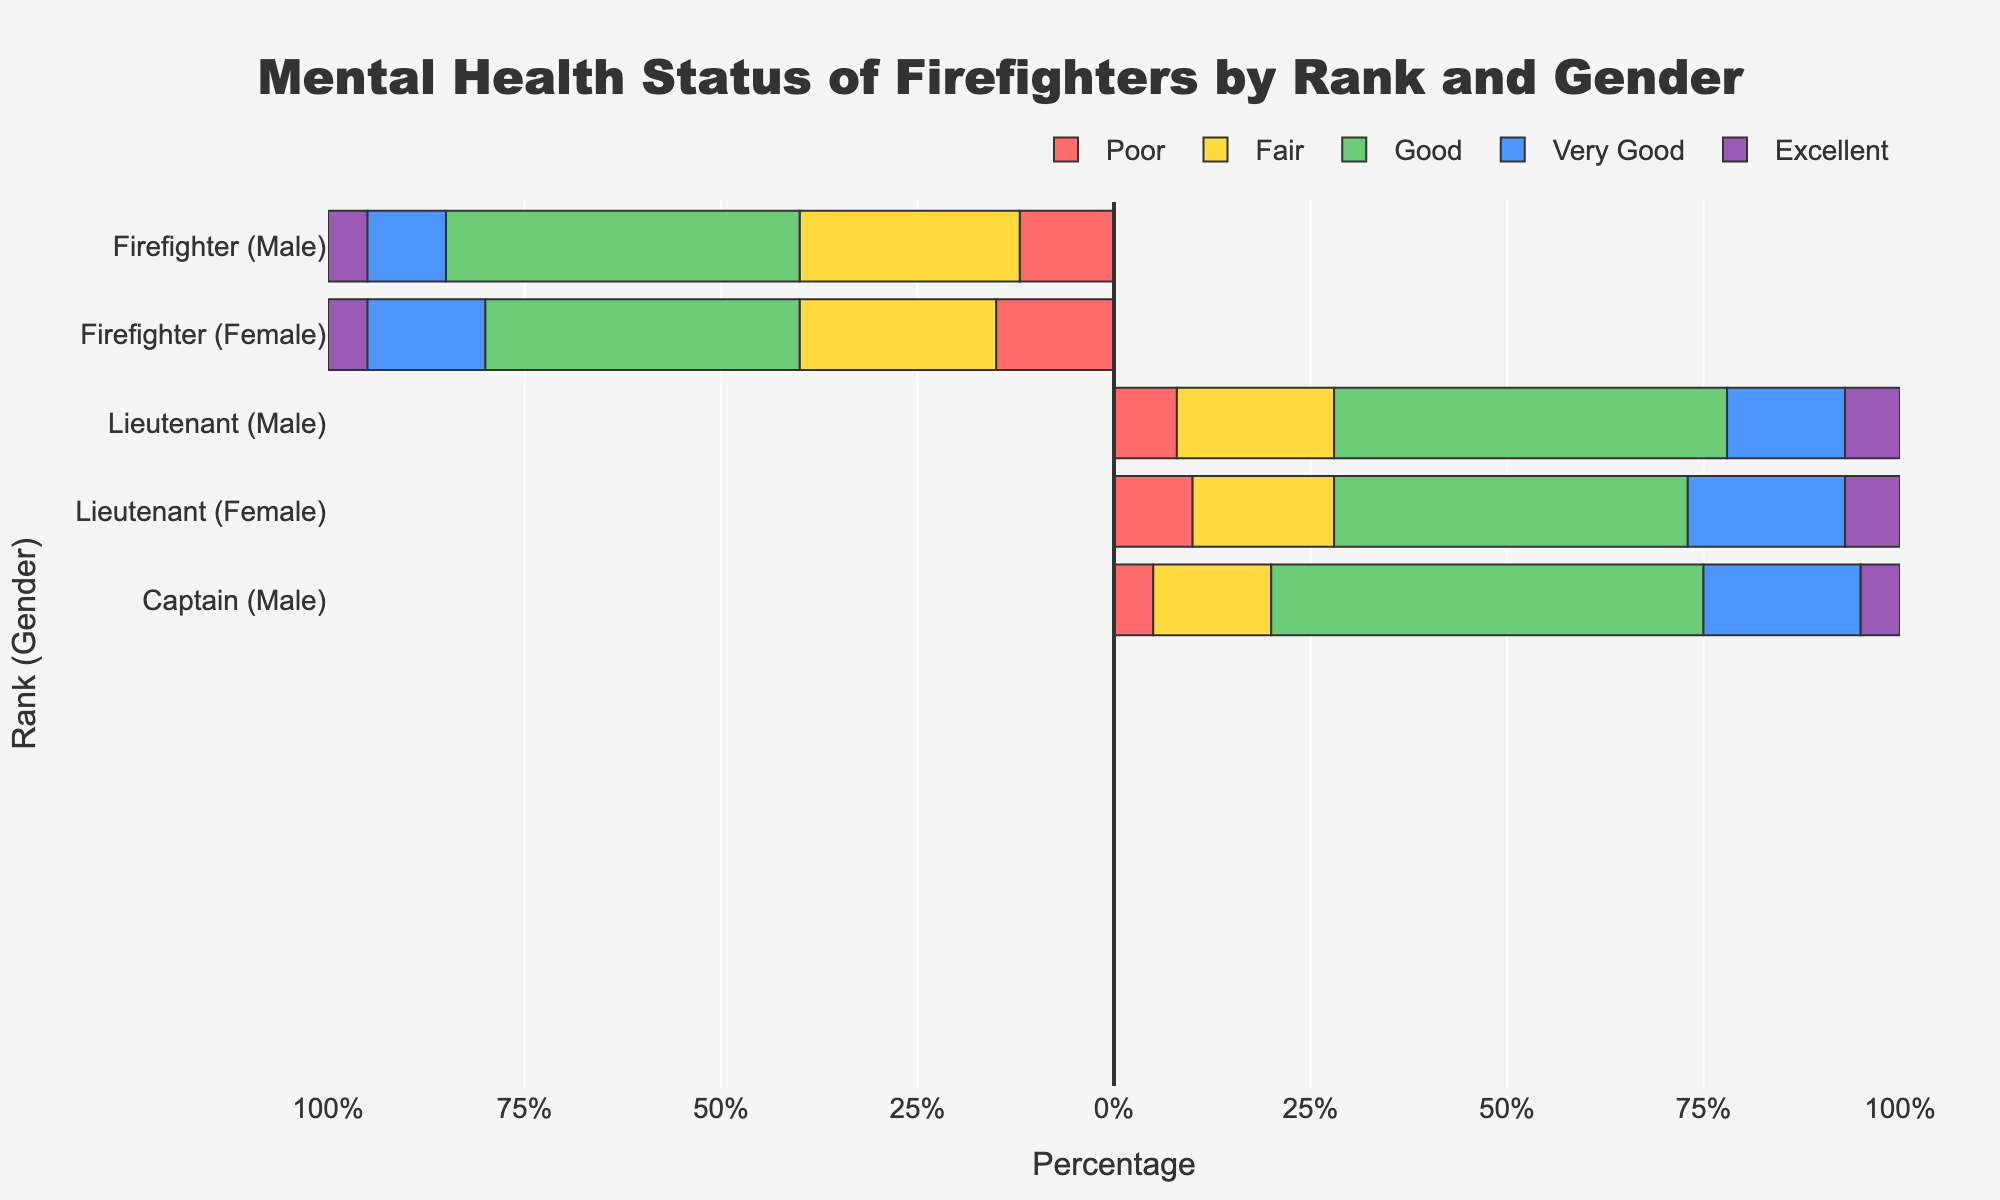What percentage of female Battalion Chiefs rate their mental health as Very Good? The figure shows a horizontal bar for Battalion Chiefs (Female). The "Very Good" category is represented by 30%, as indicated by the length of the light blue bar for that category.
Answer: 30% Which rank and gender combination has the highest percentage reporting their mental health as Excellent? The figure indicates the percentage reporting "Excellent" by the length of the purple bar. The Assistant Chief (Female) has the longest purple bar representing 14%.
Answer: Assistant Chief (Female) Between male and female Captains, which group has a higher percentage reporting their mental health as Poor? Compare the length of the red bars for Captains (Male) and Captains (Female). The red bar is longer for female Captains, showing a 8% compared to 5% for male Captains.
Answer: Female Captains What is the combined percentage of Fair and Good mental health for male Lieutenants? The respective percentages for Fair and Good mental health among male Lieutenants are represented by the yellow and green bars: 20% Fair + 50% Good = 70%.
Answer: 70% How does the percentage of Excellent mental health compare between male and female Firefighters? The percentage for Excellent mental health is shown by the length of the purple bars. Both male and female Firefighters have a 5% representation in this category.
Answer: Equal Which category (Poor, Fair, Good, Very Good, Excellent) has the smallest percentage reported by female Assistant Chiefs? Look for the shortest bar in the female Assistant Chiefs section. The shortest bar is the red one representing "Poor," which is 3%.
Answer: Poor For Battalion Chief (Male), what is the difference between the percentage reporting Good and Poor mental health? The length of the green bar (Good) is 50%, and the length of the red bar (Poor) is 3%. The difference is 50% - 3% = 47%.
Answer: 47% What visual color is used to represent the Fair mental health category across all ranks and genders? The bar representing Fair mental health is consistently yellow in color across all ranks and genders visible in the figure.
Answer: Yellow 